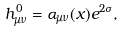Convert formula to latex. <formula><loc_0><loc_0><loc_500><loc_500>h ^ { 0 } _ { \mu \nu } = \alpha _ { \mu \nu } ( x ) e ^ { 2 \sigma } ,</formula> 